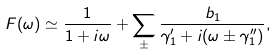<formula> <loc_0><loc_0><loc_500><loc_500>F ( \omega ) \simeq \frac { 1 } { 1 + i \omega } + \sum _ { \pm } \frac { b _ { 1 } } { \gamma ^ { \prime } _ { 1 } + i ( \omega \pm \gamma ^ { \prime \prime } _ { 1 } ) } ,</formula> 